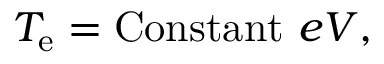<formula> <loc_0><loc_0><loc_500><loc_500>T _ { e } = C o n s t a n t \, e V ,</formula> 